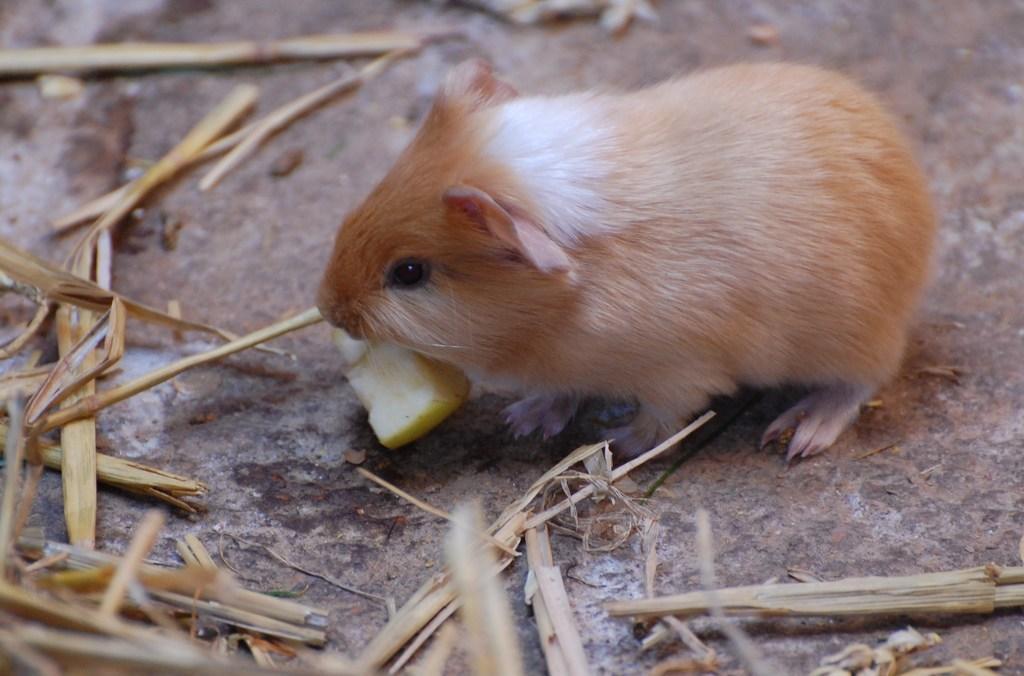Describe this image in one or two sentences. In this picture we can see a Guinea Pig and a food item on the ground. We can see some grass on the ground. 